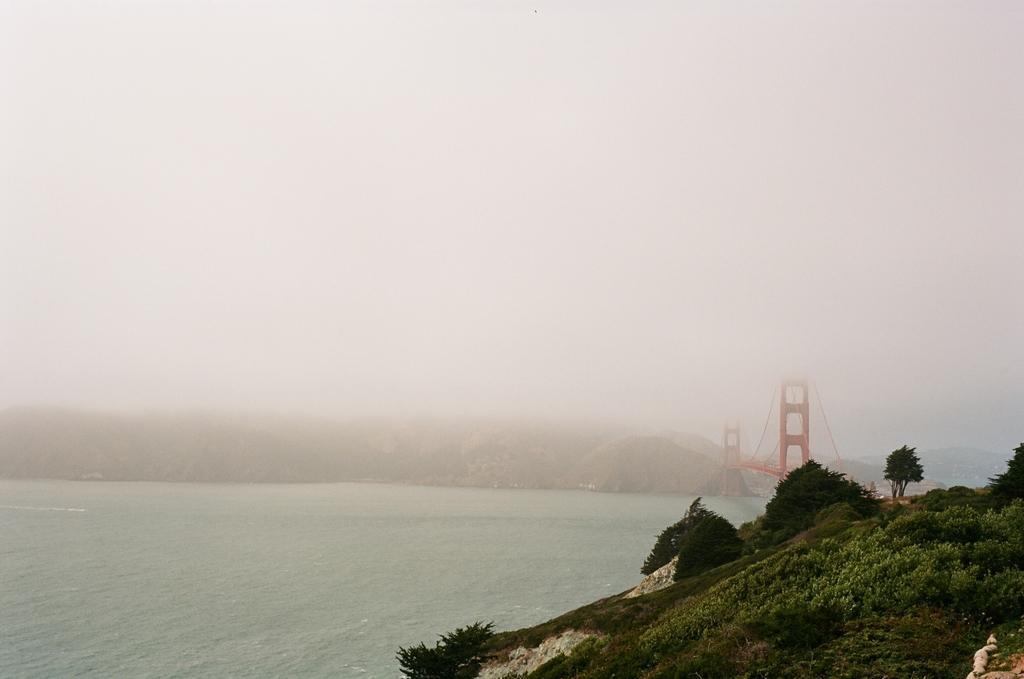Could you give a brief overview of what you see in this image? In this image we can see there is a mountain, trees, bridge and water. And at the top there is a sky. 